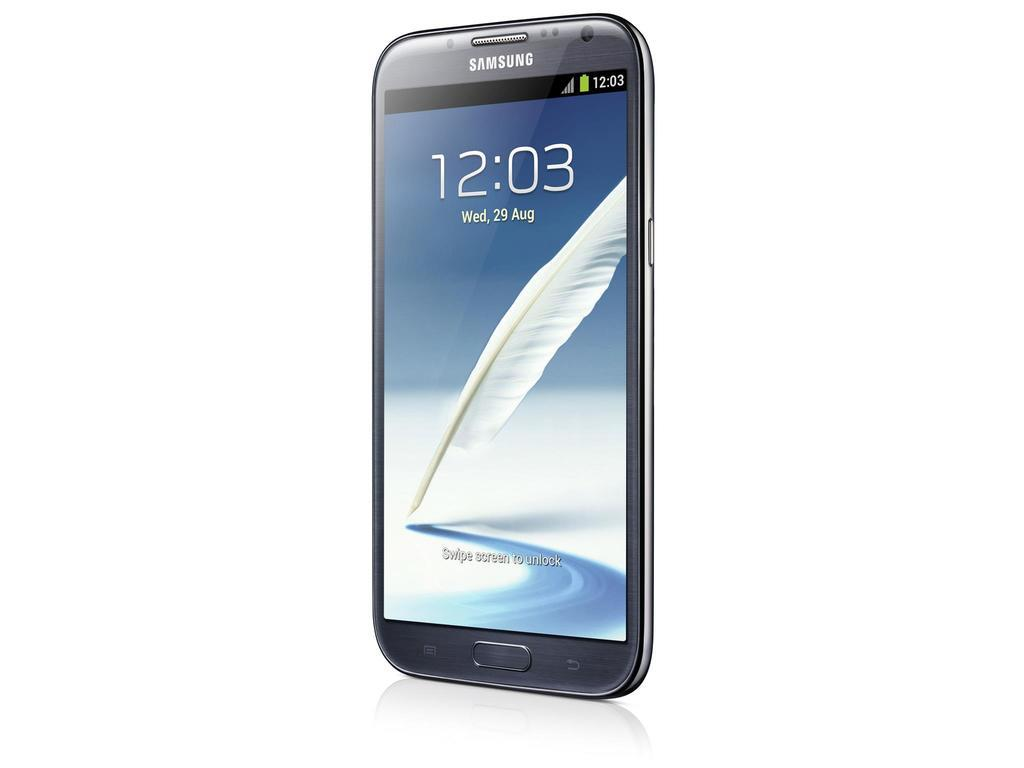<image>
Describe the image concisely. A samsung smartphone with the image of a feather on it's screen. 